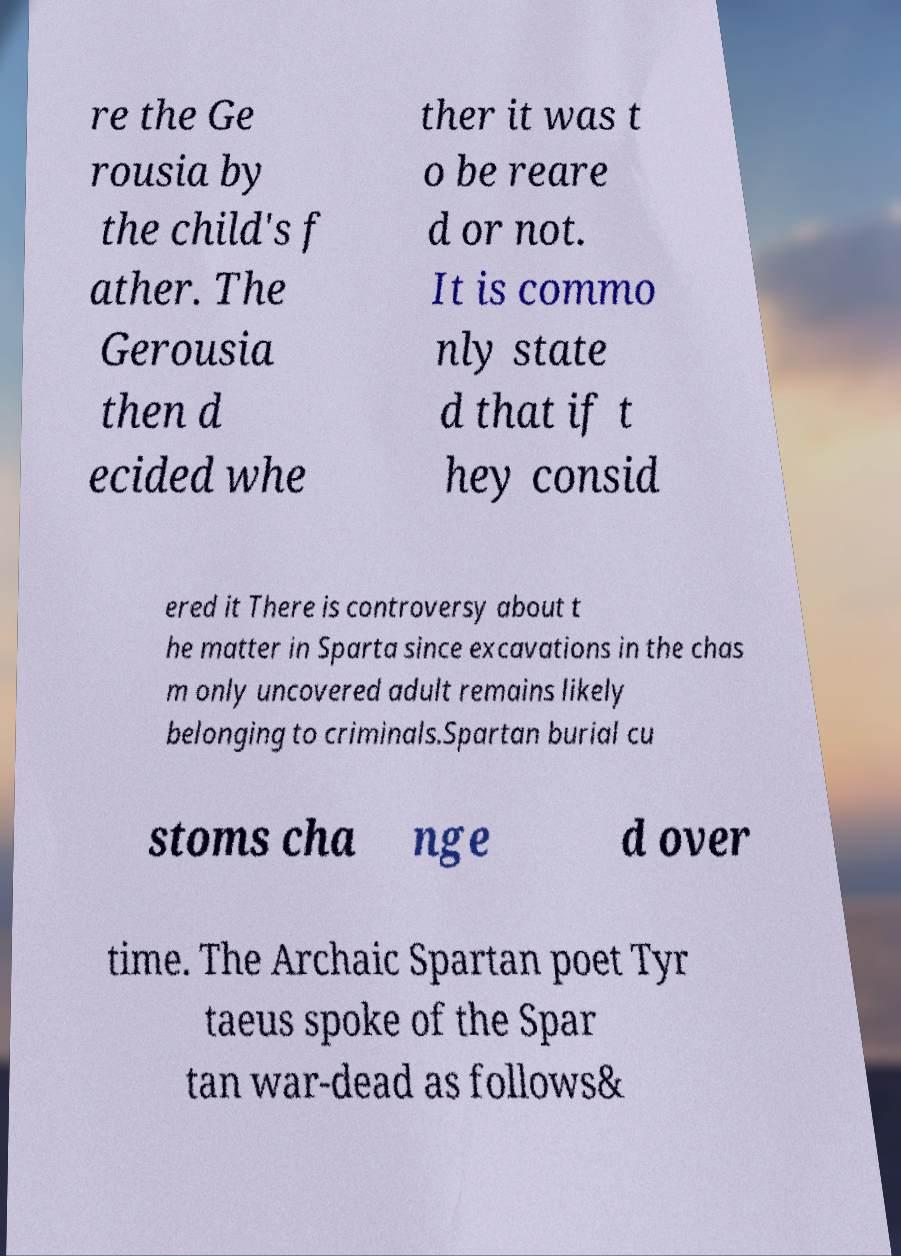Please read and relay the text visible in this image. What does it say? re the Ge rousia by the child's f ather. The Gerousia then d ecided whe ther it was t o be reare d or not. It is commo nly state d that if t hey consid ered it There is controversy about t he matter in Sparta since excavations in the chas m only uncovered adult remains likely belonging to criminals.Spartan burial cu stoms cha nge d over time. The Archaic Spartan poet Tyr taeus spoke of the Spar tan war-dead as follows& 